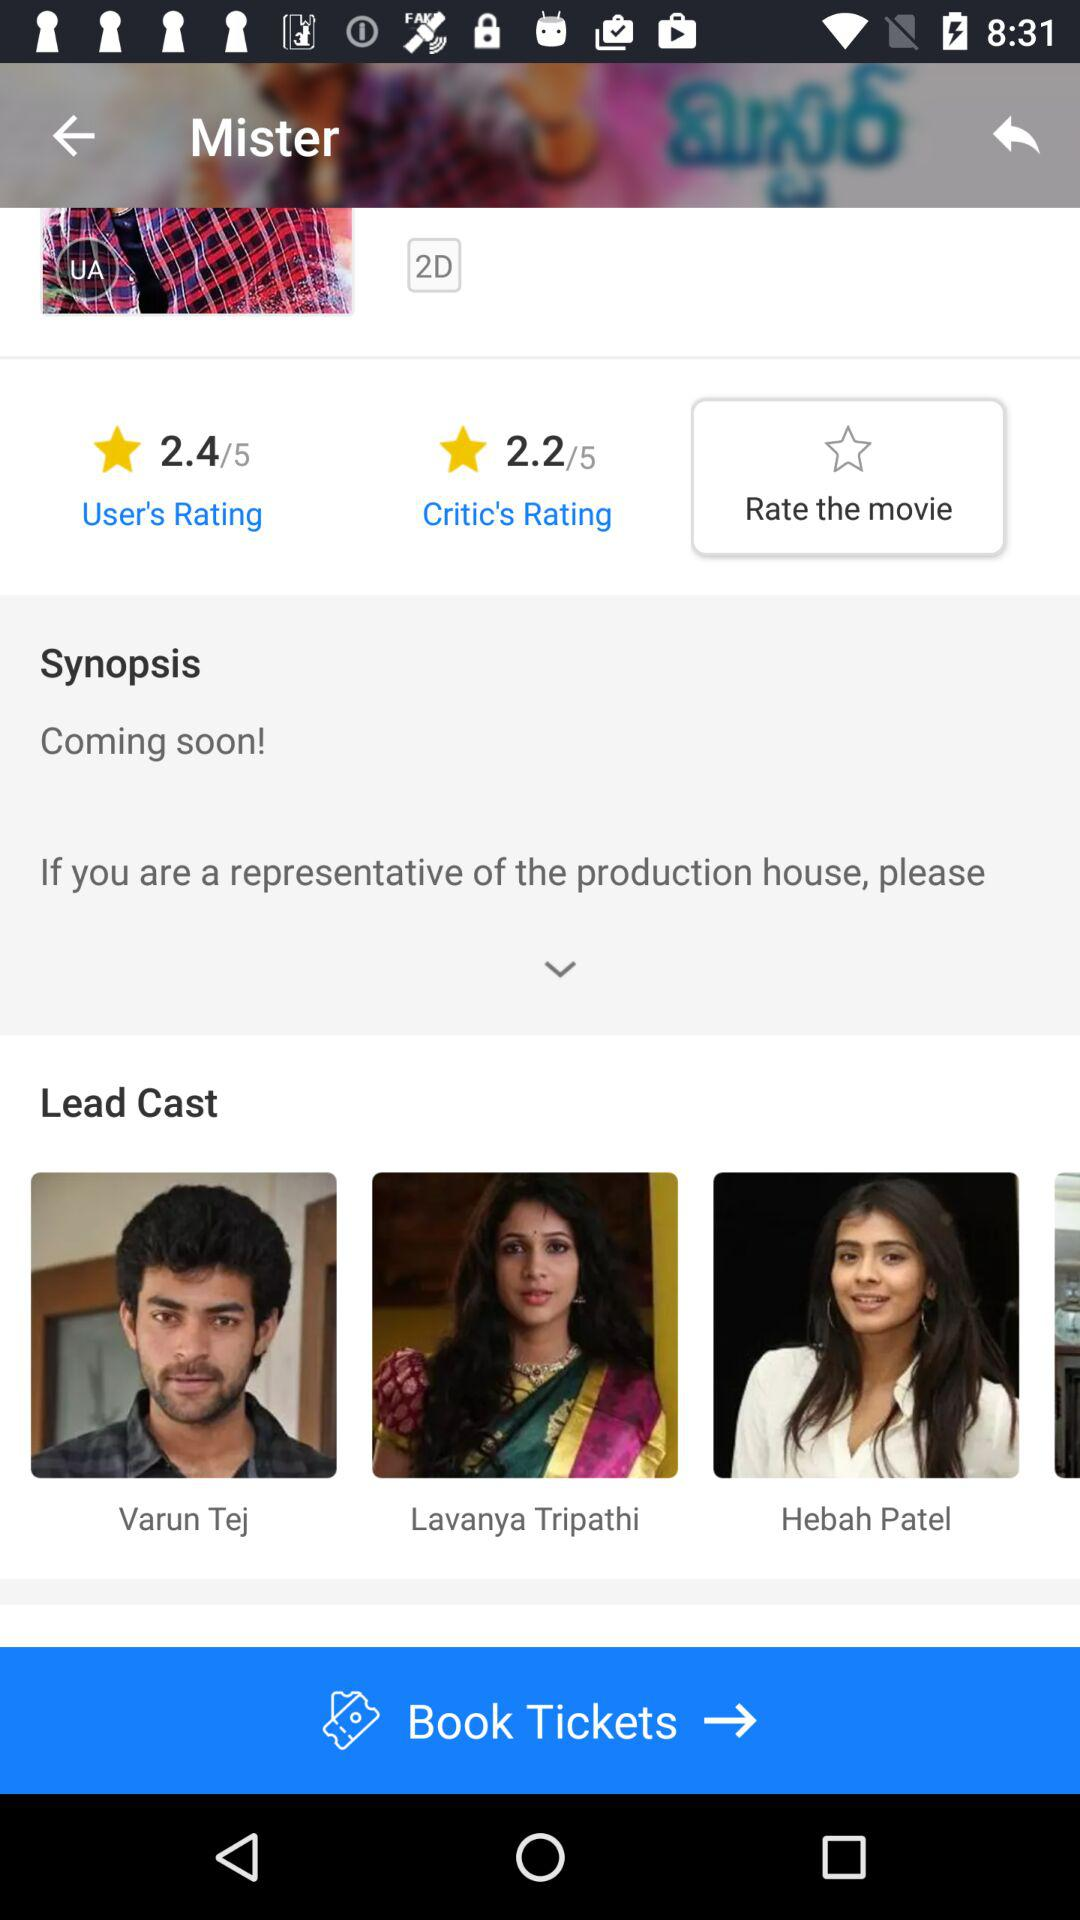What is the rating given by the critic? The rating given by the critic is 2.2. 